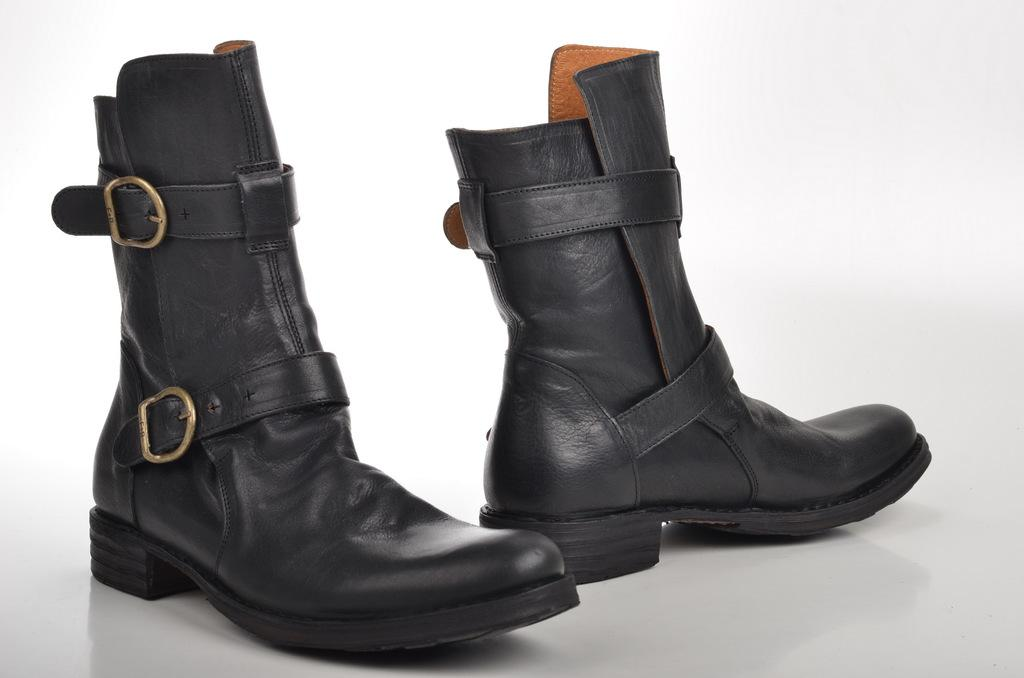What type of footwear is visible in the image? There are boots in the image. What color is the background of the image? The background of the image is white. What type of shock can be seen in the image? There is no shock present in the image; it only features boots and a white background. 